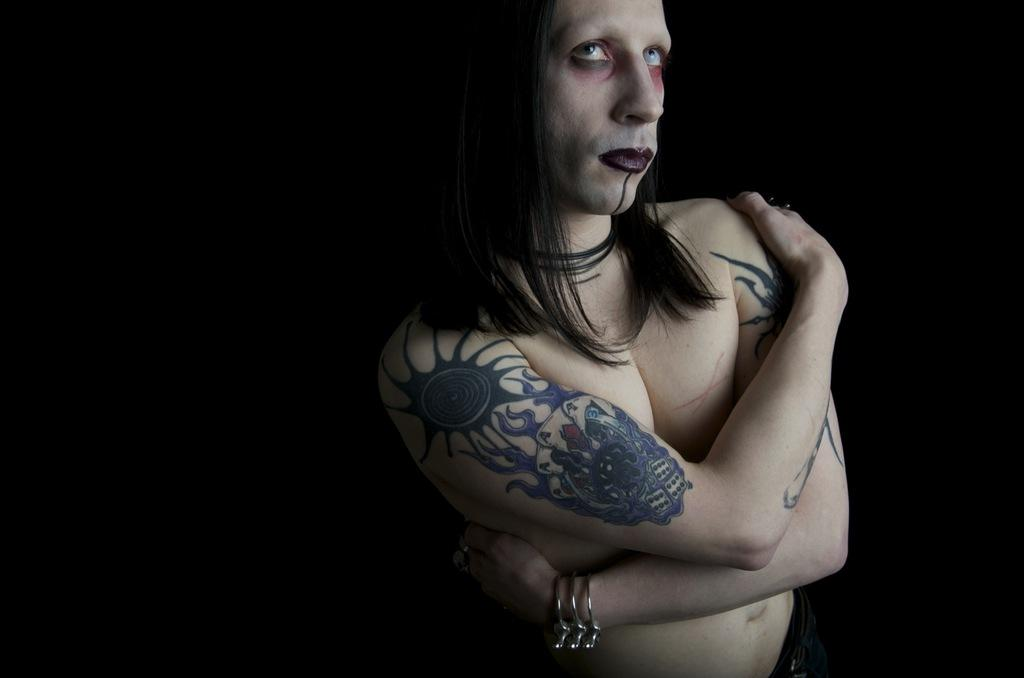What is the main subject of the image? There is a person standing in the image. Can you describe the background of the image? The background of the image is dark. How many goldfish are swimming in the oil in the image? There are no goldfish or oil present in the image; it features a person standing against a dark background. 